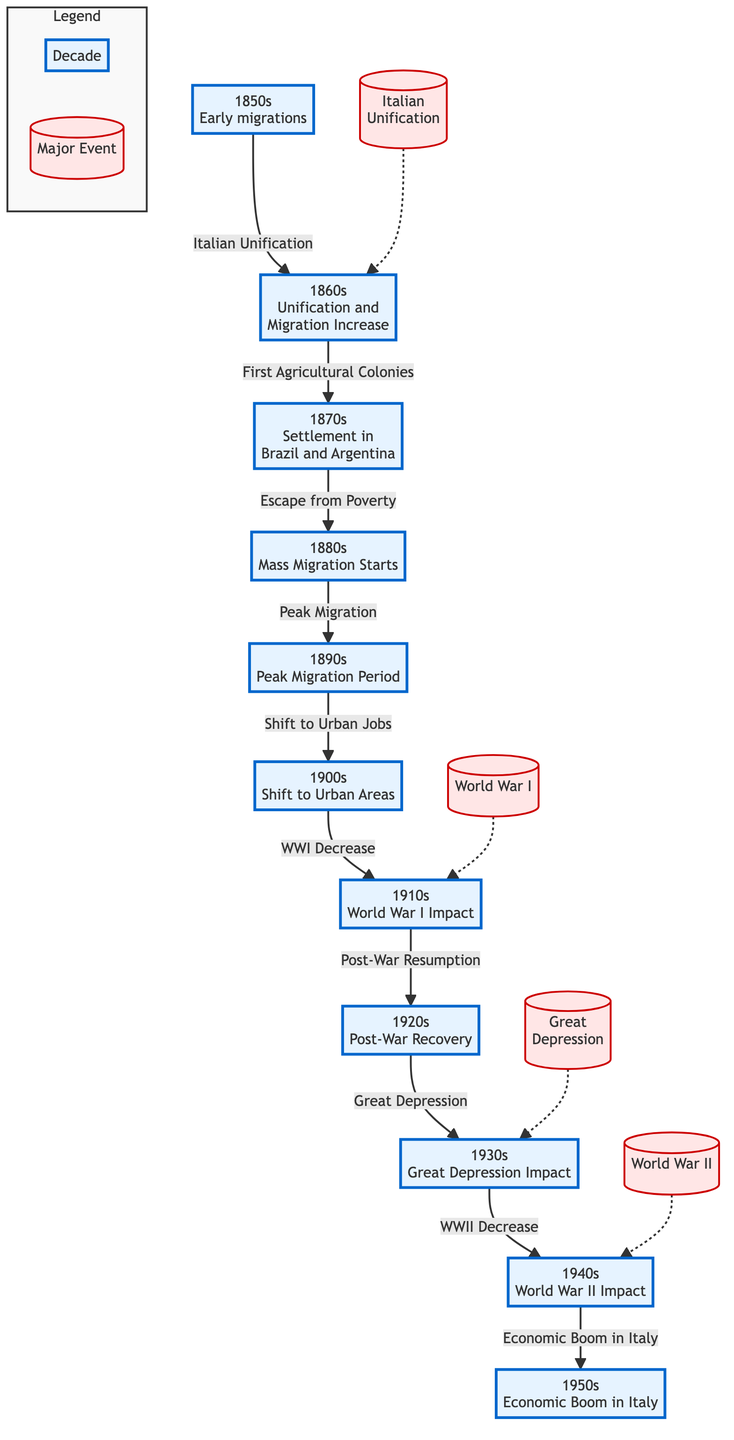What decade marked the beginning of mass migration? The diagram indicates that mass migration started in the 1880s, depicting a clear transition from earlier migration patterns to a more significant movement of Italians.
Answer: 1880s Which major event is associated with the 1860s? The flowchart specifically highlights Italian Unification as a crucial event that connects the 1850s to the 1860s, suggesting its influence on migration patterns.
Answer: Italian Unification What decade is linked to urban job shifts? The diagram shows a direct connection from the 1890s to the 1900s regarding the shift to urban jobs, indicating that this change occurred in the early 1900s.
Answer: 1900s How many decades are represented in the diagram? By counting the years labeled in the diagram, there are ten distinct decades from the 1850s to the 1950s, each marked with significant migration milestones.
Answer: 10 Which decade experienced the impact of World War I? According to the chart, the 1910s are specifically indicated as a period affected by World War I, highlighting the influence of this global conflict on migration.
Answer: 1910s What event caused a decrease in migration during the 1940s? The diagram points out that World War II had a negative impact on migration during the 1940s, directly linking this historical event to decreased migration flow.
Answer: World War II Which decade immediately follows the period of peak migration? The flowchart indicates that the peak migration period, represented by the 1890s, is followed by the decade of the 1900s, when shifts towards urbanization began.
Answer: 1900s What major event impacted immigration in the 1930s? The diagram highlights the Great Depression as the significant event impacting migration patterns during the 1930s, indicating economic challenges faced by migrants.
Answer: Great Depression What decade corresponds to the economic boom in Italy? The diagram clearly associates the economic boom in Italy with the decade of the 1950s, suggesting renewed opportunities that may influence migration flows.
Answer: 1950s 